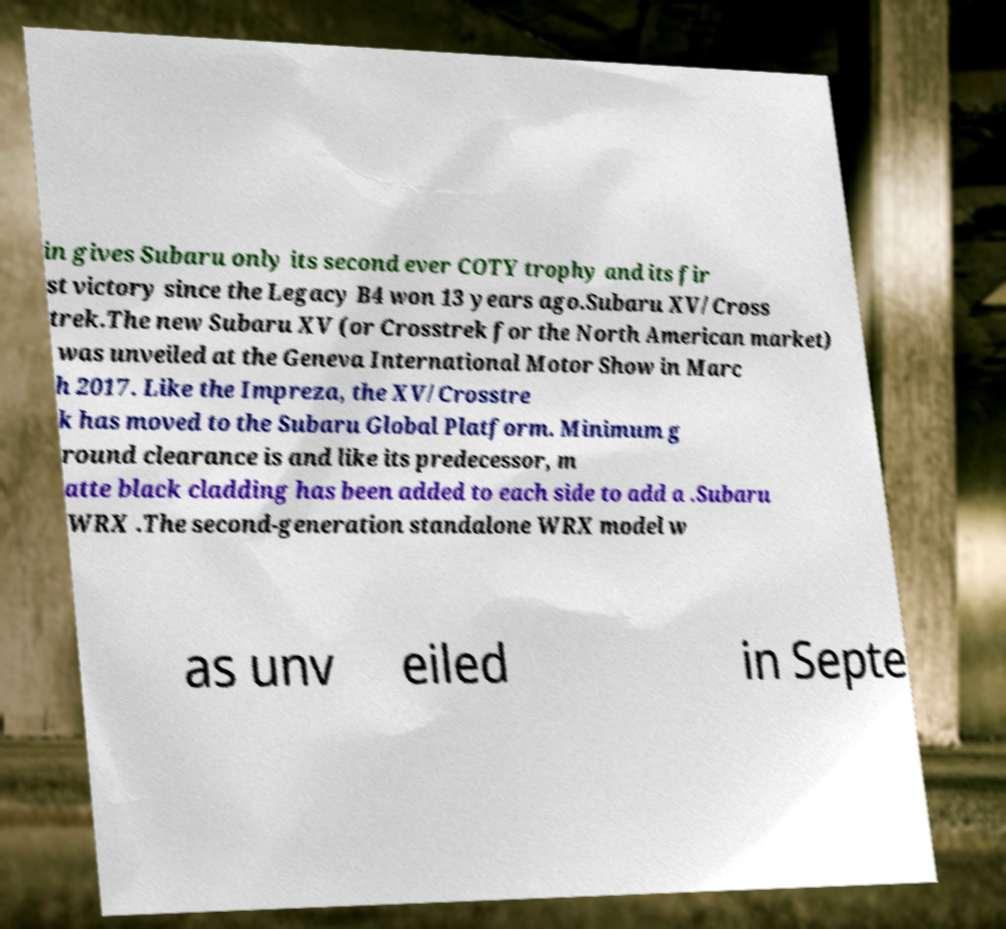Can you accurately transcribe the text from the provided image for me? in gives Subaru only its second ever COTY trophy and its fir st victory since the Legacy B4 won 13 years ago.Subaru XV/Cross trek.The new Subaru XV (or Crosstrek for the North American market) was unveiled at the Geneva International Motor Show in Marc h 2017. Like the Impreza, the XV/Crosstre k has moved to the Subaru Global Platform. Minimum g round clearance is and like its predecessor, m atte black cladding has been added to each side to add a .Subaru WRX .The second-generation standalone WRX model w as unv eiled in Septe 